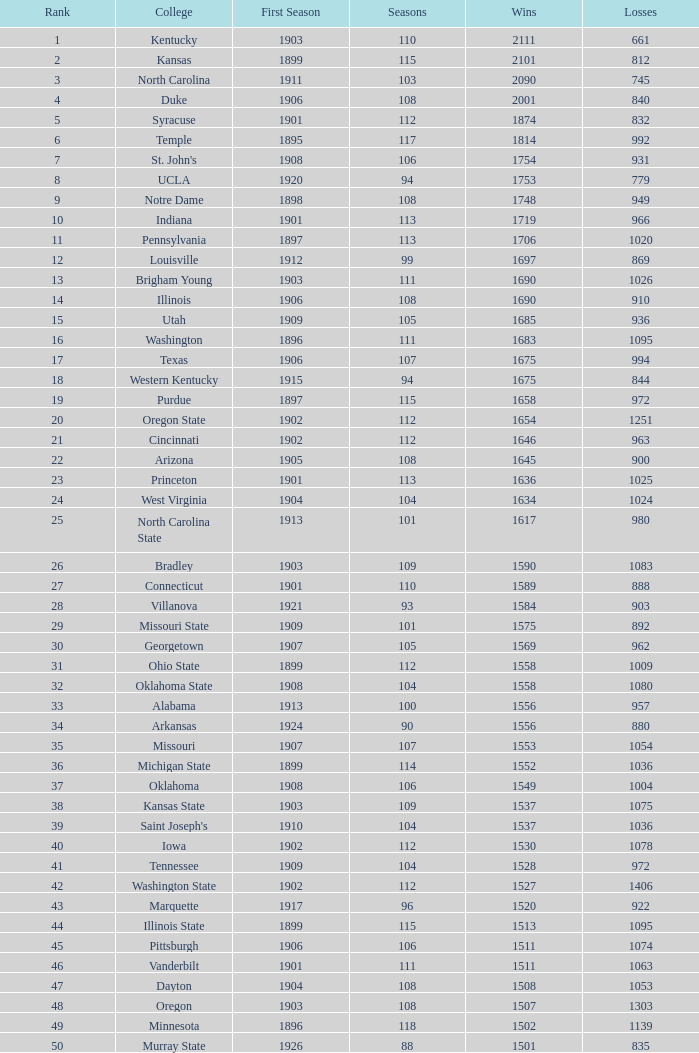What is the sum of first season matches with 1537 victories and a season exceeding 109? None. 